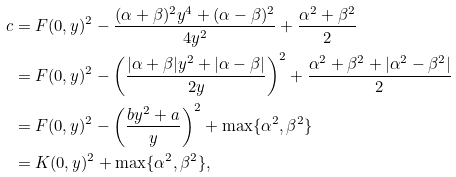Convert formula to latex. <formula><loc_0><loc_0><loc_500><loc_500>c & = F ( 0 , y ) ^ { 2 } - \frac { ( \alpha + \beta ) ^ { 2 } y ^ { 4 } + ( \alpha - \beta ) ^ { 2 } } { 4 y ^ { 2 } } + \frac { \alpha ^ { 2 } + \beta ^ { 2 } } { 2 } \\ & = F ( 0 , y ) ^ { 2 } - \left ( \frac { | \alpha + \beta | y ^ { 2 } + | \alpha - \beta | } { 2 y } \right ) ^ { 2 } + \frac { \alpha ^ { 2 } + \beta ^ { 2 } + | \alpha ^ { 2 } - \beta ^ { 2 } | } { 2 } \\ & = F ( 0 , y ) ^ { 2 } - \left ( \frac { b y ^ { 2 } + a } { y } \right ) ^ { 2 } + \max \{ \alpha ^ { 2 } , \beta ^ { 2 } \} \\ & = K ( 0 , y ) ^ { 2 } + \max \{ \alpha ^ { 2 } , \beta ^ { 2 } \} ,</formula> 